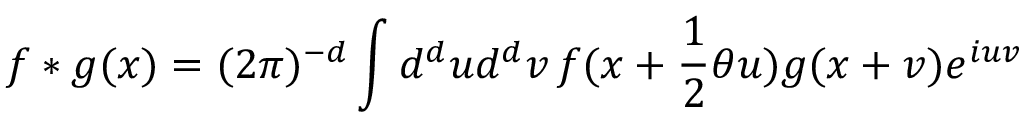<formula> <loc_0><loc_0><loc_500><loc_500>f \ast g ( x ) = ( 2 \pi ) ^ { - d } \int d ^ { d } u d ^ { d } v \, f ( x + \frac { 1 } { 2 } \theta u ) g ( x + v ) e ^ { i u v }</formula> 